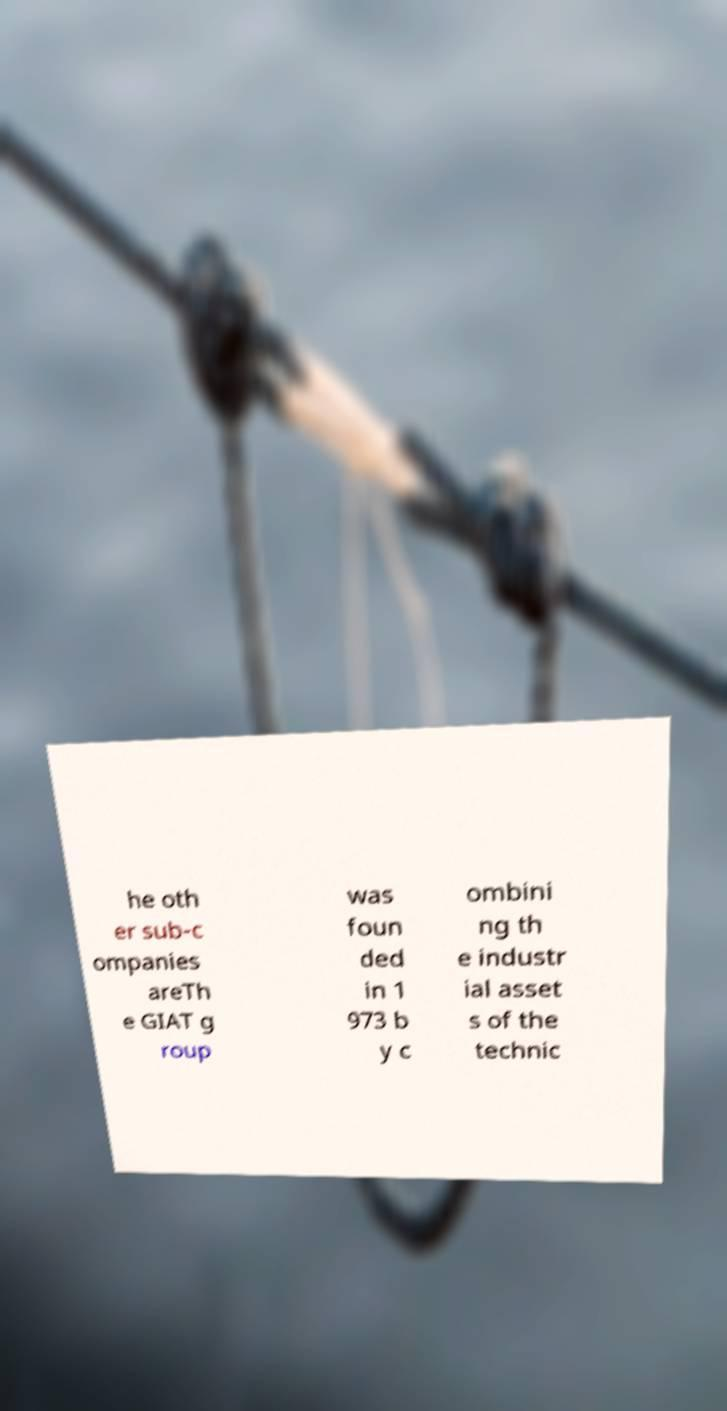Could you assist in decoding the text presented in this image and type it out clearly? he oth er sub-c ompanies areTh e GIAT g roup was foun ded in 1 973 b y c ombini ng th e industr ial asset s of the technic 